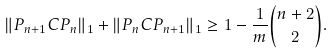Convert formula to latex. <formula><loc_0><loc_0><loc_500><loc_500>\| P _ { n + 1 } C P _ { n } \| _ { 1 } + \| P _ { n } C P _ { n + 1 } \| _ { 1 } \geq 1 - \frac { 1 } { m } \binom { n + 2 } { 2 } .</formula> 